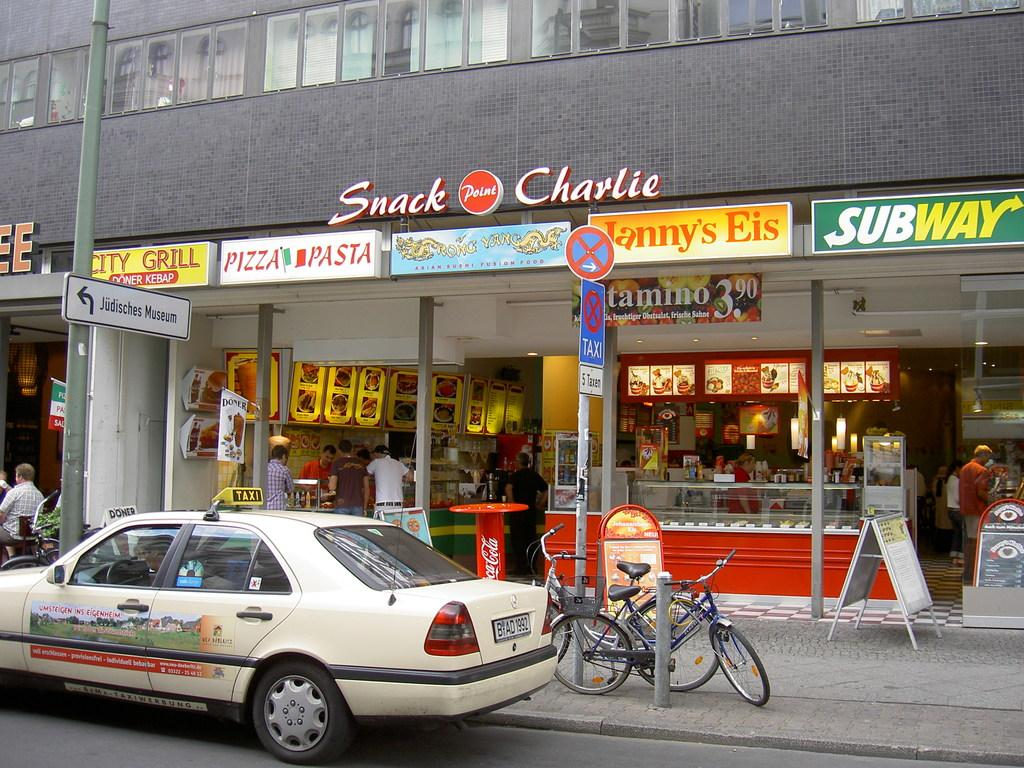<image>
Summarize the visual content of the image. A taxi parked in front of a place called Snack Charlie with a Subway. 